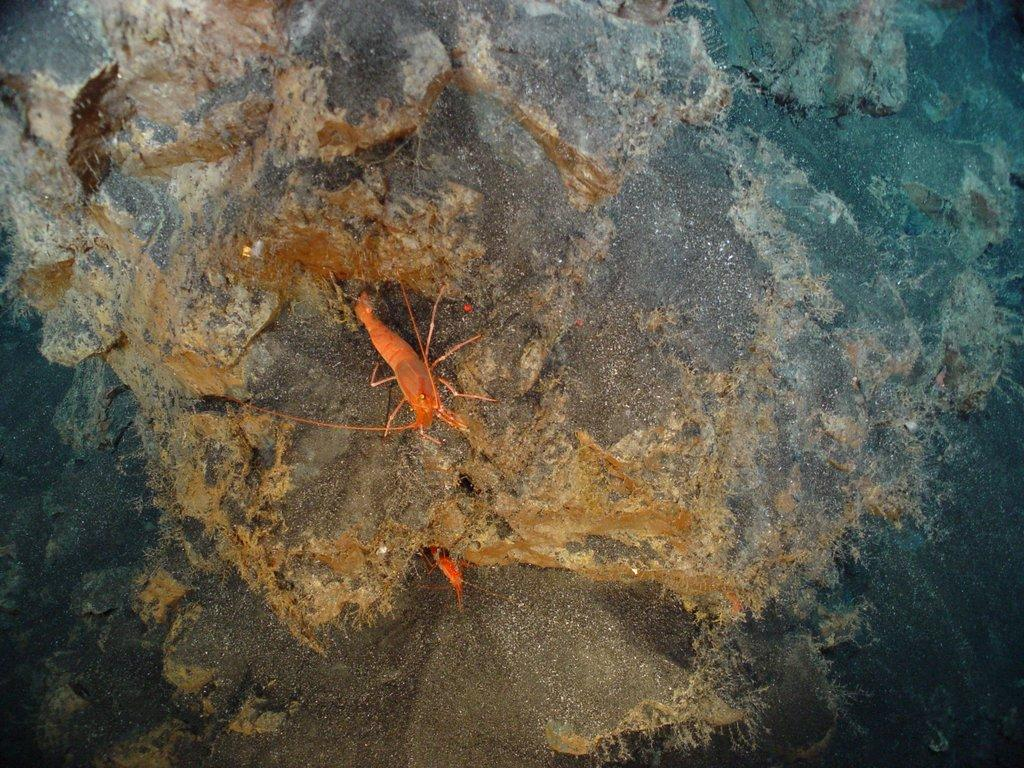What is the main subject in the image? There is a rock in the image. Are there any other objects or creatures on the rock? Yes, there are two insects on the rock. What can be said about the color of the insects? The insects are orange in color. What type of spoon is being used by the women in the image? There are no women or spoons present in the image; it features a rock with two orange insects on it. 